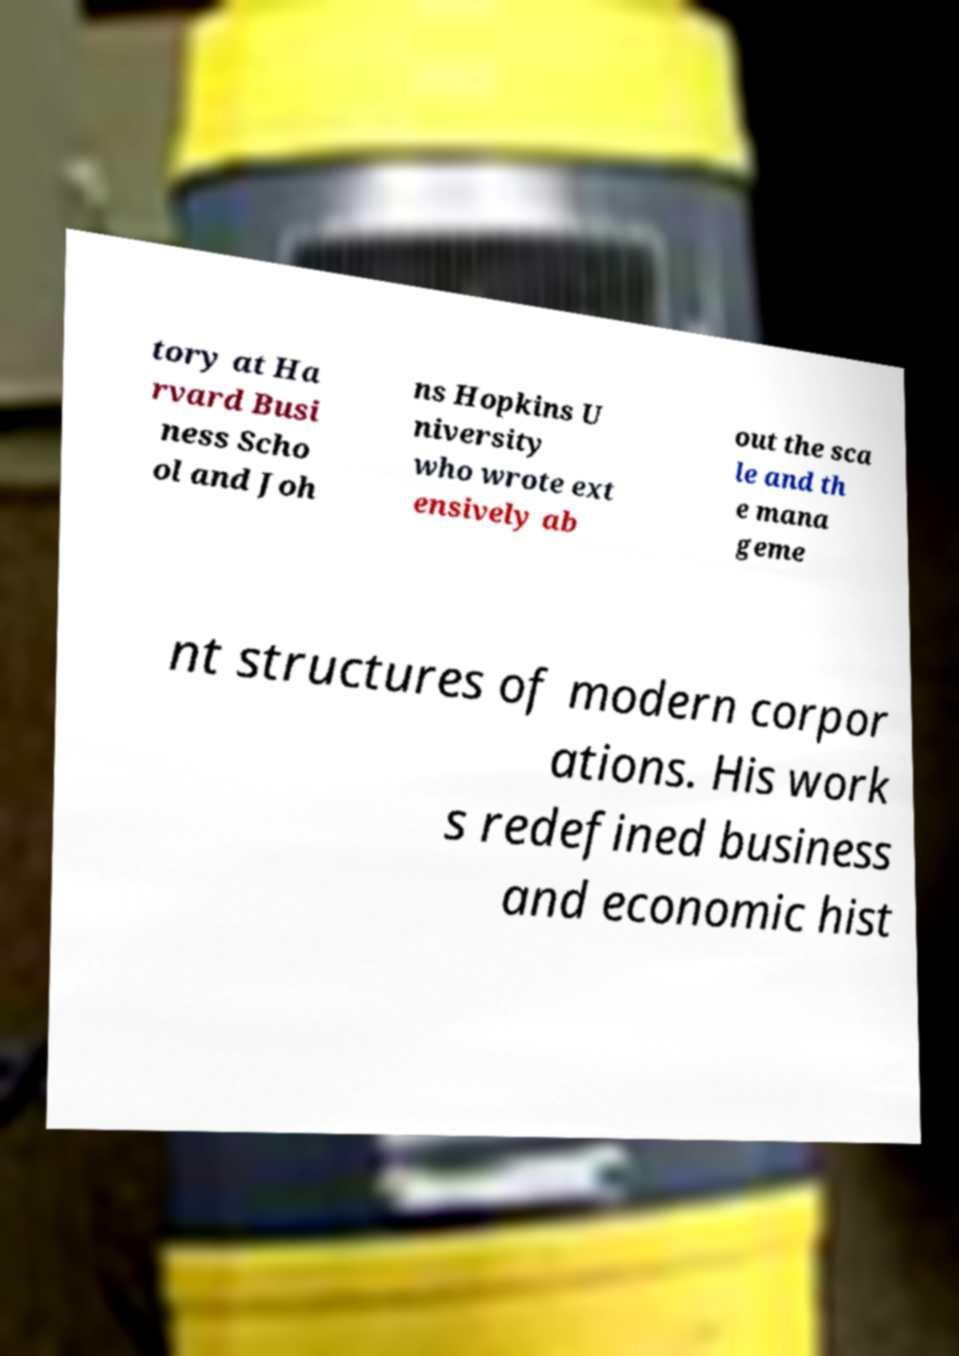Can you accurately transcribe the text from the provided image for me? tory at Ha rvard Busi ness Scho ol and Joh ns Hopkins U niversity who wrote ext ensively ab out the sca le and th e mana geme nt structures of modern corpor ations. His work s redefined business and economic hist 